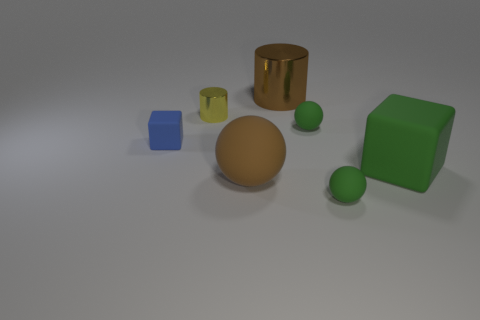Add 3 balls. How many objects exist? 10 Subtract all spheres. How many objects are left? 4 Subtract all big green rubber objects. Subtract all blue matte blocks. How many objects are left? 5 Add 5 large matte balls. How many large matte balls are left? 6 Add 6 purple things. How many purple things exist? 6 Subtract 0 blue balls. How many objects are left? 7 